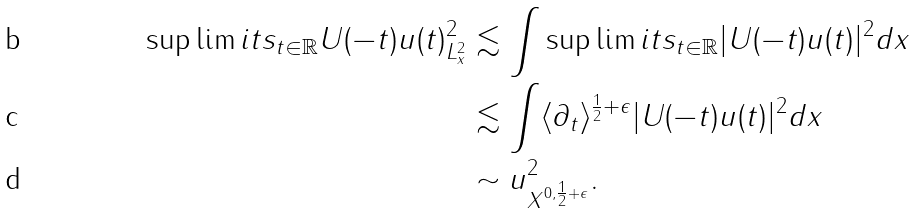Convert formula to latex. <formula><loc_0><loc_0><loc_500><loc_500>\sup \lim i t s _ { t \in \mathbb { R } } \| U ( - t ) u ( t ) \| _ { L ^ { 2 } _ { x } } ^ { 2 } & \lesssim \int \sup \lim i t s _ { t \in \mathbb { R } } | U ( - t ) u ( t ) | ^ { 2 } d x \\ & \lesssim \int \langle \partial _ { t } \rangle ^ { \frac { 1 } { 2 } + \epsilon } | U ( - t ) u ( t ) | ^ { 2 } d x \\ & \sim \| u \| ^ { 2 } _ { X ^ { 0 , \frac { 1 } { 2 } + \epsilon } } .</formula> 